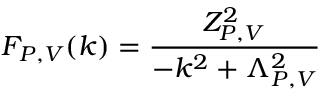Convert formula to latex. <formula><loc_0><loc_0><loc_500><loc_500>F _ { P , V } ( k ) = \frac { Z _ { P , V } ^ { 2 } } { - k ^ { 2 } + \Lambda _ { P , V } ^ { 2 } }</formula> 